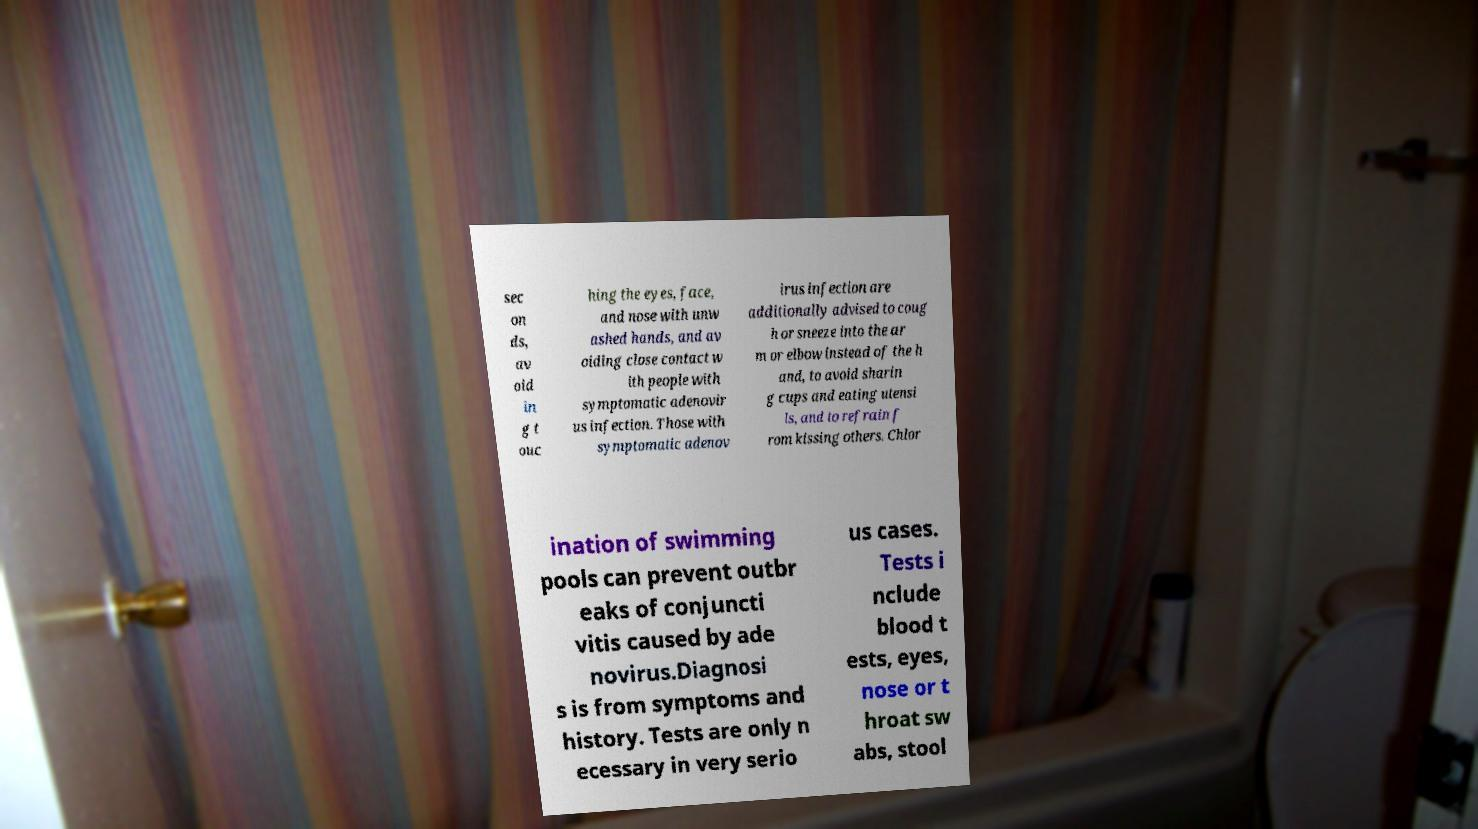For documentation purposes, I need the text within this image transcribed. Could you provide that? sec on ds, av oid in g t ouc hing the eyes, face, and nose with unw ashed hands, and av oiding close contact w ith people with symptomatic adenovir us infection. Those with symptomatic adenov irus infection are additionally advised to coug h or sneeze into the ar m or elbow instead of the h and, to avoid sharin g cups and eating utensi ls, and to refrain f rom kissing others. Chlor ination of swimming pools can prevent outbr eaks of conjuncti vitis caused by ade novirus.Diagnosi s is from symptoms and history. Tests are only n ecessary in very serio us cases. Tests i nclude blood t ests, eyes, nose or t hroat sw abs, stool 